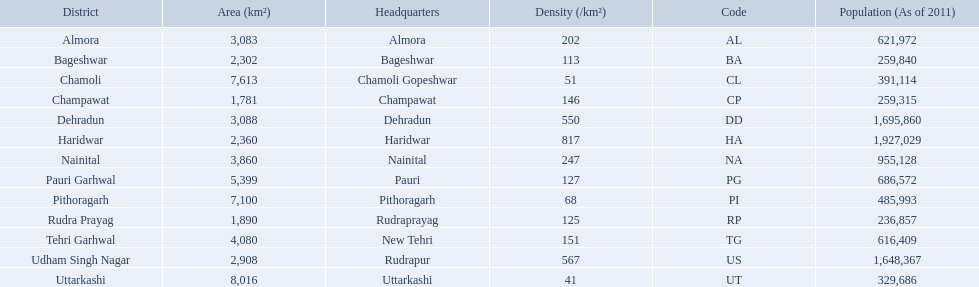What are the values for density of the districts of uttrakhand? 202, 113, 51, 146, 550, 817, 247, 127, 68, 125, 151, 567, 41. Can you give me this table as a dict? {'header': ['District', 'Area (km²)', 'Headquarters', 'Density (/km²)', 'Code', 'Population (As of 2011)'], 'rows': [['Almora', '3,083', 'Almora', '202', 'AL', '621,972'], ['Bageshwar', '2,302', 'Bageshwar', '113', 'BA', '259,840'], ['Chamoli', '7,613', 'Chamoli Gopeshwar', '51', 'CL', '391,114'], ['Champawat', '1,781', 'Champawat', '146', 'CP', '259,315'], ['Dehradun', '3,088', 'Dehradun', '550', 'DD', '1,695,860'], ['Haridwar', '2,360', 'Haridwar', '817', 'HA', '1,927,029'], ['Nainital', '3,860', 'Nainital', '247', 'NA', '955,128'], ['Pauri Garhwal', '5,399', 'Pauri', '127', 'PG', '686,572'], ['Pithoragarh', '7,100', 'Pithoragarh', '68', 'PI', '485,993'], ['Rudra Prayag', '1,890', 'Rudraprayag', '125', 'RP', '236,857'], ['Tehri Garhwal', '4,080', 'New Tehri', '151', 'TG', '616,409'], ['Udham Singh Nagar', '2,908', 'Rudrapur', '567', 'US', '1,648,367'], ['Uttarkashi', '8,016', 'Uttarkashi', '41', 'UT', '329,686']]} Which district has value of 51? Chamoli. 